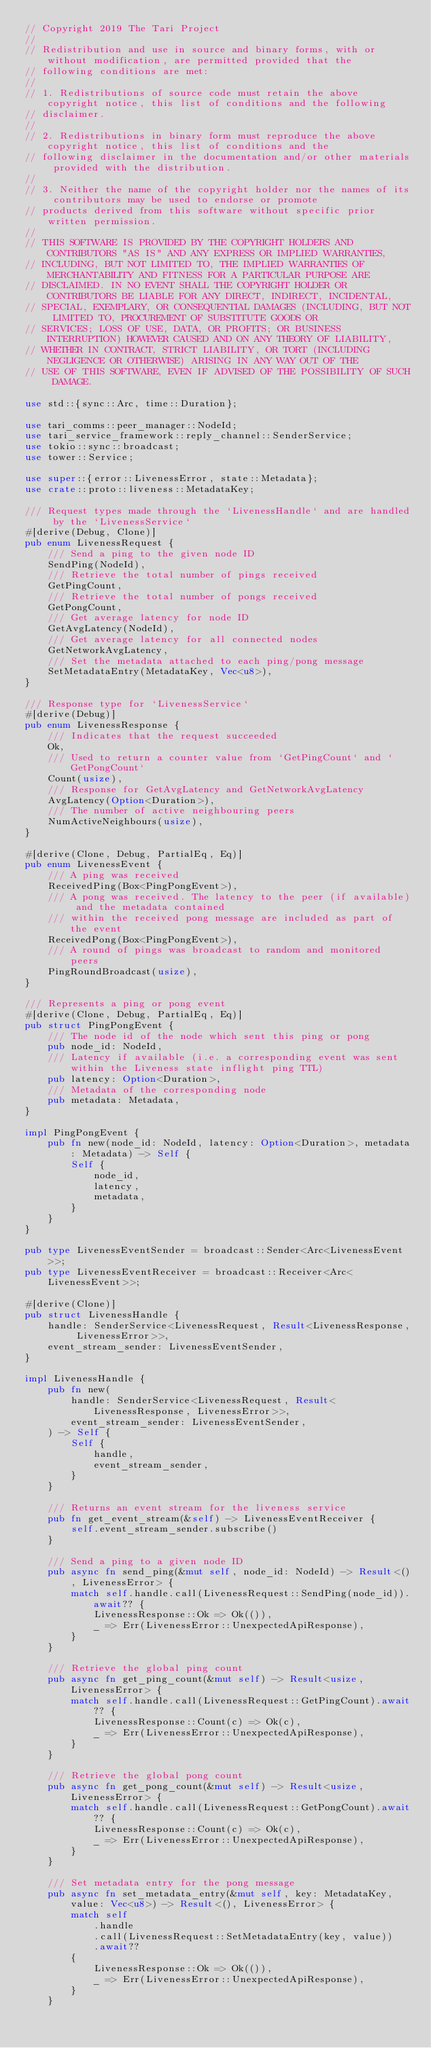<code> <loc_0><loc_0><loc_500><loc_500><_Rust_>// Copyright 2019 The Tari Project
//
// Redistribution and use in source and binary forms, with or without modification, are permitted provided that the
// following conditions are met:
//
// 1. Redistributions of source code must retain the above copyright notice, this list of conditions and the following
// disclaimer.
//
// 2. Redistributions in binary form must reproduce the above copyright notice, this list of conditions and the
// following disclaimer in the documentation and/or other materials provided with the distribution.
//
// 3. Neither the name of the copyright holder nor the names of its contributors may be used to endorse or promote
// products derived from this software without specific prior written permission.
//
// THIS SOFTWARE IS PROVIDED BY THE COPYRIGHT HOLDERS AND CONTRIBUTORS "AS IS" AND ANY EXPRESS OR IMPLIED WARRANTIES,
// INCLUDING, BUT NOT LIMITED TO, THE IMPLIED WARRANTIES OF MERCHANTABILITY AND FITNESS FOR A PARTICULAR PURPOSE ARE
// DISCLAIMED. IN NO EVENT SHALL THE COPYRIGHT HOLDER OR CONTRIBUTORS BE LIABLE FOR ANY DIRECT, INDIRECT, INCIDENTAL,
// SPECIAL, EXEMPLARY, OR CONSEQUENTIAL DAMAGES (INCLUDING, BUT NOT LIMITED TO, PROCUREMENT OF SUBSTITUTE GOODS OR
// SERVICES; LOSS OF USE, DATA, OR PROFITS; OR BUSINESS INTERRUPTION) HOWEVER CAUSED AND ON ANY THEORY OF LIABILITY,
// WHETHER IN CONTRACT, STRICT LIABILITY, OR TORT (INCLUDING NEGLIGENCE OR OTHERWISE) ARISING IN ANY WAY OUT OF THE
// USE OF THIS SOFTWARE, EVEN IF ADVISED OF THE POSSIBILITY OF SUCH DAMAGE.

use std::{sync::Arc, time::Duration};

use tari_comms::peer_manager::NodeId;
use tari_service_framework::reply_channel::SenderService;
use tokio::sync::broadcast;
use tower::Service;

use super::{error::LivenessError, state::Metadata};
use crate::proto::liveness::MetadataKey;

/// Request types made through the `LivenessHandle` and are handled by the `LivenessService`
#[derive(Debug, Clone)]
pub enum LivenessRequest {
    /// Send a ping to the given node ID
    SendPing(NodeId),
    /// Retrieve the total number of pings received
    GetPingCount,
    /// Retrieve the total number of pongs received
    GetPongCount,
    /// Get average latency for node ID
    GetAvgLatency(NodeId),
    /// Get average latency for all connected nodes
    GetNetworkAvgLatency,
    /// Set the metadata attached to each ping/pong message
    SetMetadataEntry(MetadataKey, Vec<u8>),
}

/// Response type for `LivenessService`
#[derive(Debug)]
pub enum LivenessResponse {
    /// Indicates that the request succeeded
    Ok,
    /// Used to return a counter value from `GetPingCount` and `GetPongCount`
    Count(usize),
    /// Response for GetAvgLatency and GetNetworkAvgLatency
    AvgLatency(Option<Duration>),
    /// The number of active neighbouring peers
    NumActiveNeighbours(usize),
}

#[derive(Clone, Debug, PartialEq, Eq)]
pub enum LivenessEvent {
    /// A ping was received
    ReceivedPing(Box<PingPongEvent>),
    /// A pong was received. The latency to the peer (if available) and the metadata contained
    /// within the received pong message are included as part of the event
    ReceivedPong(Box<PingPongEvent>),
    /// A round of pings was broadcast to random and monitored peers
    PingRoundBroadcast(usize),
}

/// Represents a ping or pong event
#[derive(Clone, Debug, PartialEq, Eq)]
pub struct PingPongEvent {
    /// The node id of the node which sent this ping or pong
    pub node_id: NodeId,
    /// Latency if available (i.e. a corresponding event was sent within the Liveness state inflight ping TTL)
    pub latency: Option<Duration>,
    /// Metadata of the corresponding node
    pub metadata: Metadata,
}

impl PingPongEvent {
    pub fn new(node_id: NodeId, latency: Option<Duration>, metadata: Metadata) -> Self {
        Self {
            node_id,
            latency,
            metadata,
        }
    }
}

pub type LivenessEventSender = broadcast::Sender<Arc<LivenessEvent>>;
pub type LivenessEventReceiver = broadcast::Receiver<Arc<LivenessEvent>>;

#[derive(Clone)]
pub struct LivenessHandle {
    handle: SenderService<LivenessRequest, Result<LivenessResponse, LivenessError>>,
    event_stream_sender: LivenessEventSender,
}

impl LivenessHandle {
    pub fn new(
        handle: SenderService<LivenessRequest, Result<LivenessResponse, LivenessError>>,
        event_stream_sender: LivenessEventSender,
    ) -> Self {
        Self {
            handle,
            event_stream_sender,
        }
    }

    /// Returns an event stream for the liveness service
    pub fn get_event_stream(&self) -> LivenessEventReceiver {
        self.event_stream_sender.subscribe()
    }

    /// Send a ping to a given node ID
    pub async fn send_ping(&mut self, node_id: NodeId) -> Result<(), LivenessError> {
        match self.handle.call(LivenessRequest::SendPing(node_id)).await?? {
            LivenessResponse::Ok => Ok(()),
            _ => Err(LivenessError::UnexpectedApiResponse),
        }
    }

    /// Retrieve the global ping count
    pub async fn get_ping_count(&mut self) -> Result<usize, LivenessError> {
        match self.handle.call(LivenessRequest::GetPingCount).await?? {
            LivenessResponse::Count(c) => Ok(c),
            _ => Err(LivenessError::UnexpectedApiResponse),
        }
    }

    /// Retrieve the global pong count
    pub async fn get_pong_count(&mut self) -> Result<usize, LivenessError> {
        match self.handle.call(LivenessRequest::GetPongCount).await?? {
            LivenessResponse::Count(c) => Ok(c),
            _ => Err(LivenessError::UnexpectedApiResponse),
        }
    }

    /// Set metadata entry for the pong message
    pub async fn set_metadata_entry(&mut self, key: MetadataKey, value: Vec<u8>) -> Result<(), LivenessError> {
        match self
            .handle
            .call(LivenessRequest::SetMetadataEntry(key, value))
            .await??
        {
            LivenessResponse::Ok => Ok(()),
            _ => Err(LivenessError::UnexpectedApiResponse),
        }
    }
</code> 